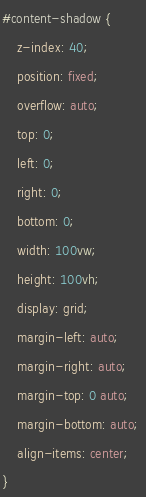Convert code to text. <code><loc_0><loc_0><loc_500><loc_500><_CSS_>#content-shadow {
	z-index: 40;
	position: fixed;
	overflow: auto;
	top: 0;
	left: 0;
	right: 0;
	bottom: 0;
	width: 100vw;
	height: 100vh;
	display: grid;
	margin-left: auto;
	margin-right: auto; 
	margin-top: 0 auto; 
	margin-bottom: auto;
	align-items: center;	
}
</code> 